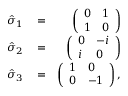<formula> <loc_0><loc_0><loc_500><loc_500>\begin{array} { r l r } { \hat { \sigma } _ { 1 } } & = } & { \left ( \begin{array} { l l } { 0 } & { 1 } \\ { 1 } & { 0 } \end{array} \right ) } \\ { \hat { \sigma } _ { 2 } } & = } & { \left ( \begin{array} { l l } { 0 } & { - i } \\ { i } & { 0 } \end{array} \right ) } \\ { \hat { \sigma } _ { 3 } } & = } & { \left ( \begin{array} { l l } { 1 } & { 0 } \\ { 0 } & { - 1 } \end{array} \right ) , } \end{array}</formula> 